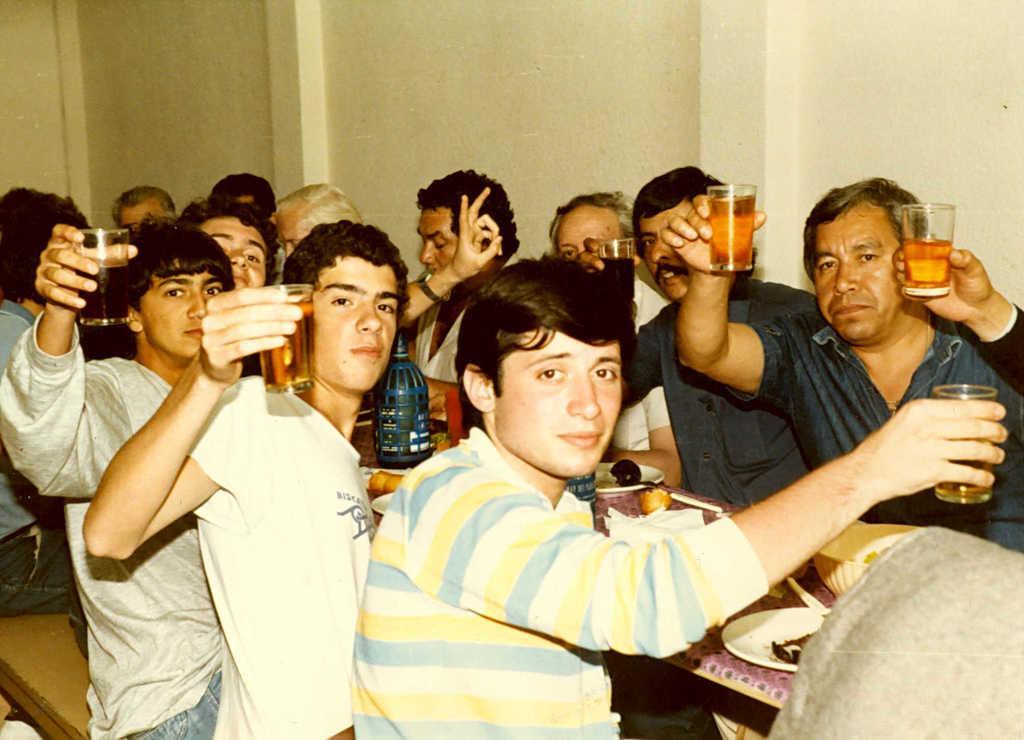In one or two sentences, can you explain what this image depicts? In the image we can see group of persons were sitting on the bench around the table and they were holding wine glasses. On table,we can see bottle,plate,bowl and food item. In the background there is a wall. 